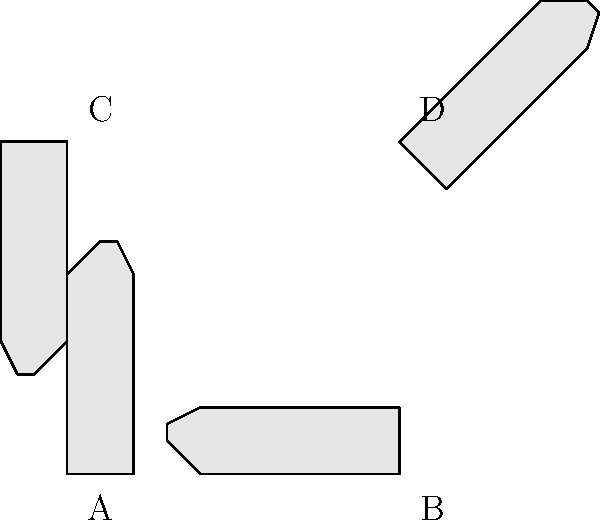As a body language expert, identify which of the illustrated hand gestures (A, B, C, or D) most likely represents a "stop" or "halt" signal in nonverbal communication. To identify the hand gesture that most likely represents a "stop" or "halt" signal, let's analyze each gesture:

1. Gesture A: The hand is shown in a vertical position with fingers pointing upwards. This gesture is commonly used for greetings, voting, or indicating the number five.

2. Gesture B: The hand is rotated 90 degrees clockwise, with fingers pointing to the right. This position is not typically associated with any common nonverbal signals.

3. Gesture C: The hand is rotated 180 degrees, with fingers pointing downwards. This gesture can be interpreted as a "thumbs down" or disapproval signal, but it's not typically used for "stop" or "halt."

4. Gesture D: The hand is rotated approximately 45 degrees counterclockwise, with the palm facing forward and fingers pointing diagonally upward. This gesture most closely resembles the universal "stop" or "halt" signal.

The "stop" or "halt" gesture is typically performed with the palm facing forward and fingers pointing upward. This position creates a clear visual barrier, effectively communicating the message to stop or pause. Gesture D most closely matches this description, as the palm is facing forward and the fingers are angled upward, creating the characteristic "stop" signal.
Answer: D 